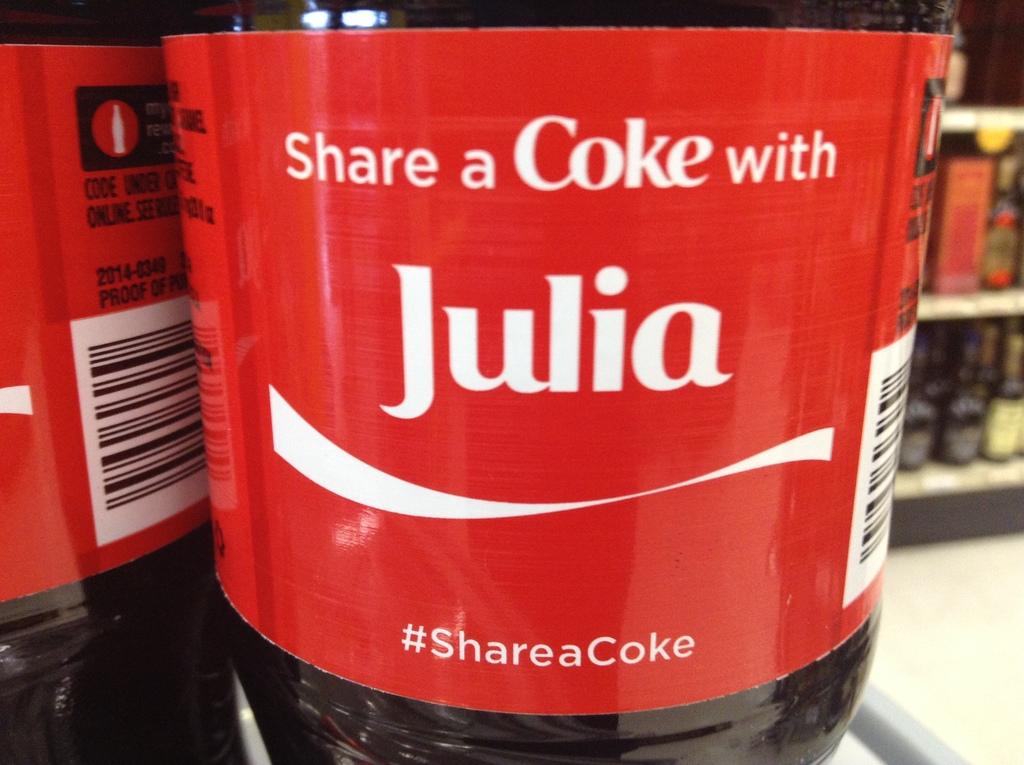What is the person name on the bottle?
Your answer should be very brief. Julia. What is the hashtag on the label?
Keep it short and to the point. #shareacoke. 